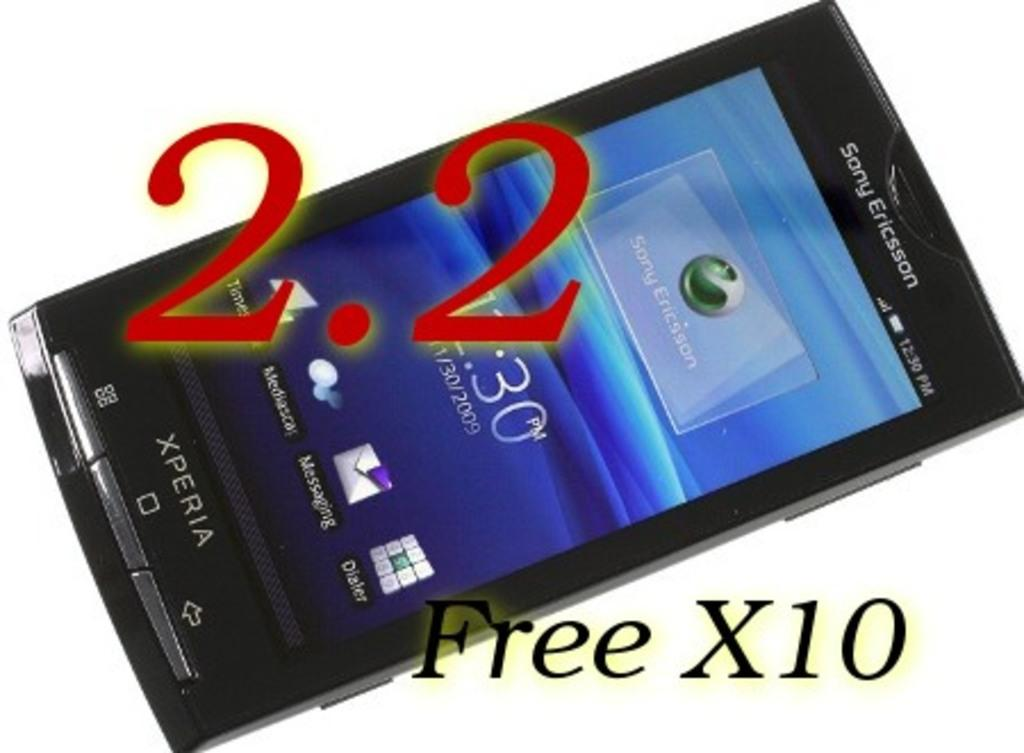<image>
Summarize the visual content of the image. A smart phone says Sony Ericsson across the top. 